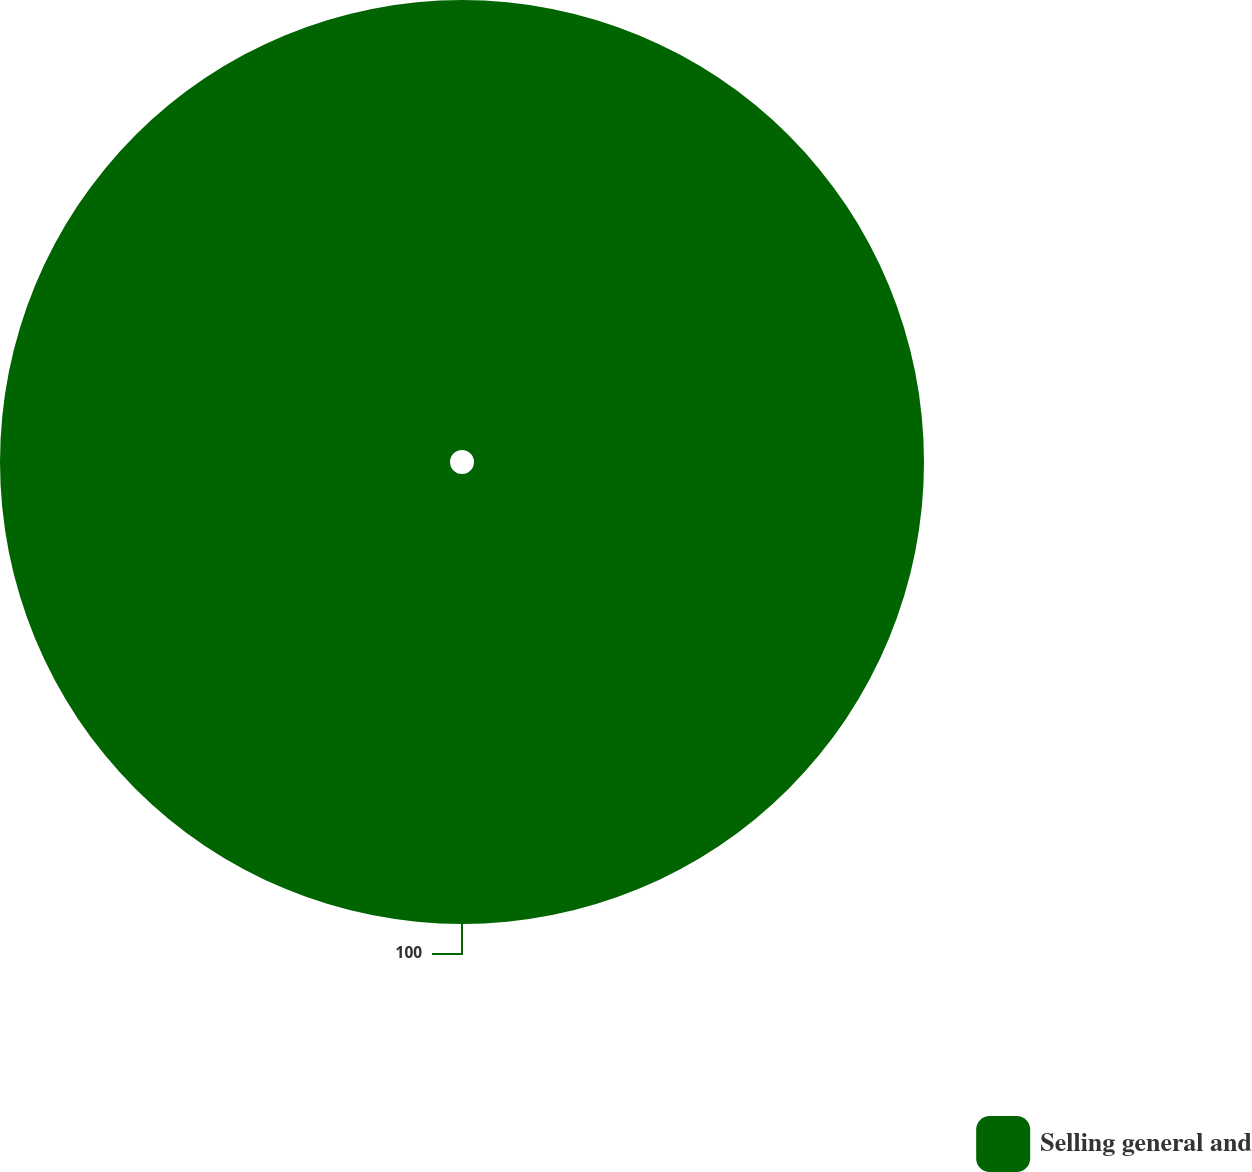<chart> <loc_0><loc_0><loc_500><loc_500><pie_chart><fcel>Selling general and<nl><fcel>100.0%<nl></chart> 